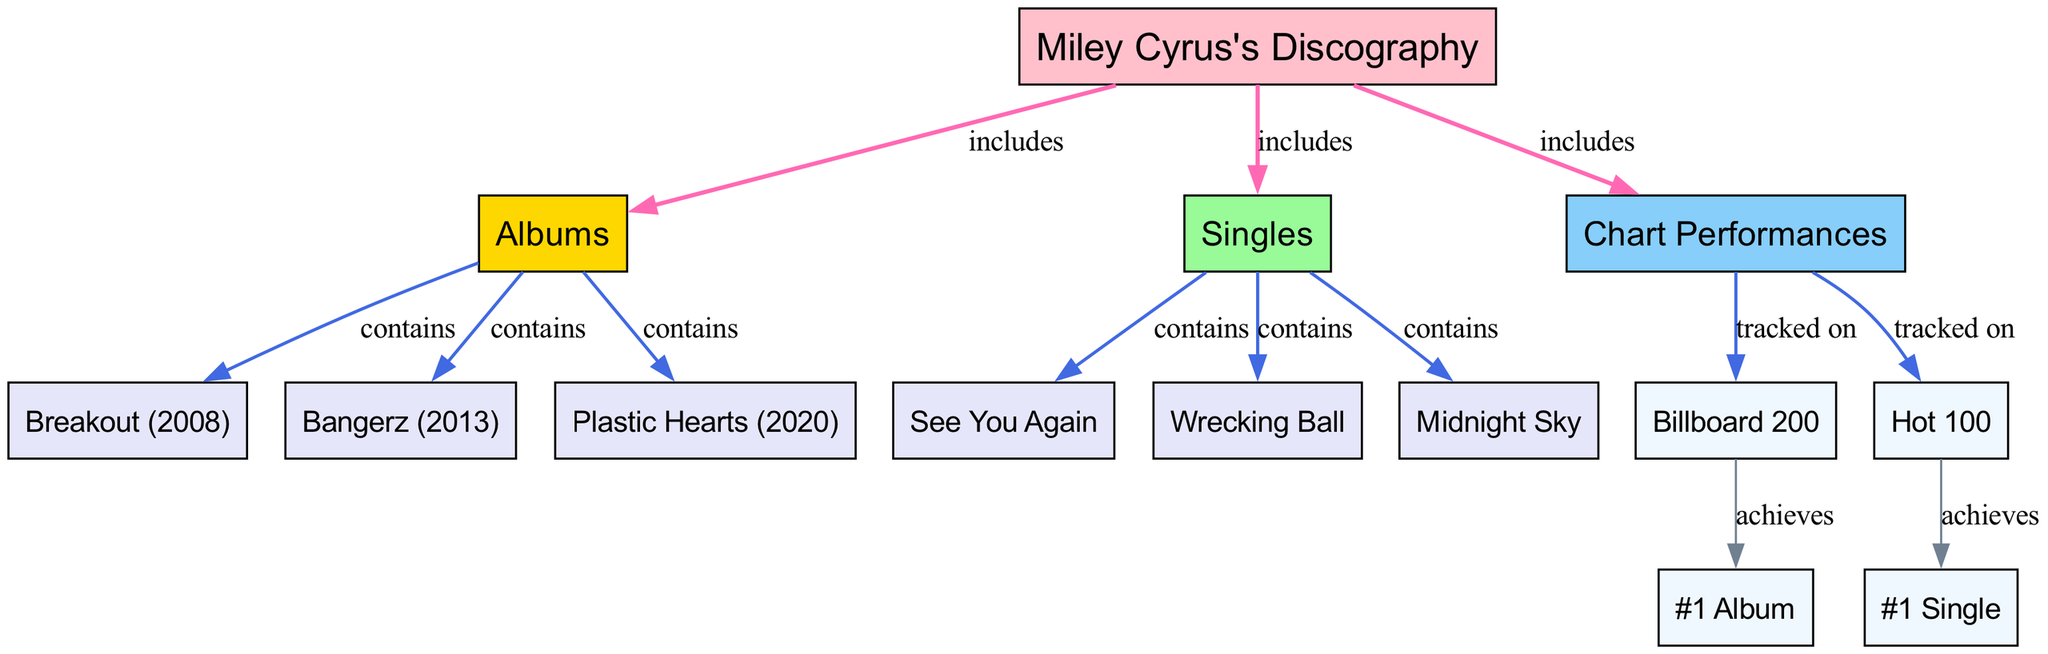What are the main components of Miley Cyrus's discography? The diagram indicates that Miley Cyrus's discography consists of three main components: Albums, Singles, and Chart Performances. These components are connected to the main node that represents her discography.
Answer: Albums, Singles, Chart Performances How many albums are listed in the diagram? According to the diagram, there are three albums displayed: Breakout (2008), Bangerz (2013), and Plastic Hearts (2020). Each album is directly connected to the "Albums" node, indicating that they are part of Miley Cyrus's discography.
Answer: 3 Which single is associated with the highest chart performance? The diagram shows that "Wrecking Ball" is connected to the "#1 Single" node from the "Singles" section. This suggests that "Wrecking Ball" is recognized as having achieved the highest performance, indicating it has reached the top of the charts.
Answer: Wrecking Ball What type of performance is tracked on the Billboard 200? The diagram points out that the "Billboard 200" node is linked to the "Chart Performances" section, revealing that it tracks the performance of albums. Alongside it, the "#1 Album" node indicates that it recognizes when an album achieves the top position.
Answer: Album performance How is the relationship between Miley Cyrus's albums and chart performances depicted? The diagram illustrates that the albums are included under the main discography node, which is also connected to the chart performances section. The "Billboard 200" node, linked to the "#1 Album" node, signifies that the albums are tracked for their achievements on this chart.
Answer: Included and tracked Which album is listed as released in 2020? Within the diagram, the release year for the album "Plastic Hearts" is labeled as 2020. This distinct connection under the "Albums" node helps to identify the year associated with this particular album.
Answer: Plastic Hearts 